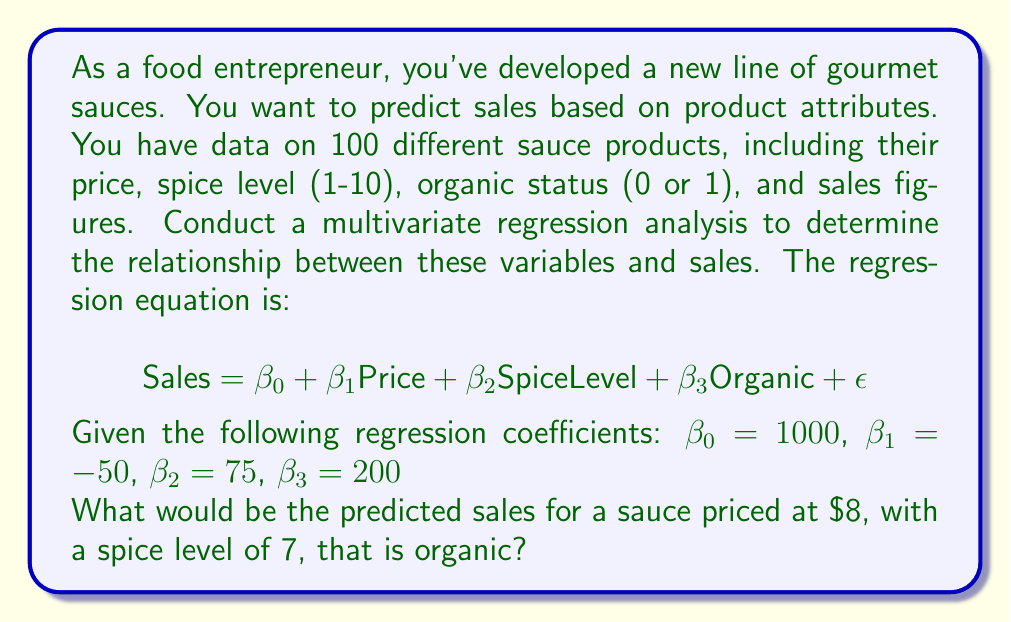Could you help me with this problem? To solve this problem, we'll follow these steps:

1. Understand the regression equation:
   $$\text{Sales} = \beta_0 + \beta_1\text{Price} + \beta_2\text{SpiceLevel} + \beta_3\text{Organic} + \epsilon$$

   Where:
   - $\beta_0$ is the y-intercept (baseline sales)
   - $\beta_1$ is the coefficient for Price
   - $\beta_2$ is the coefficient for Spice Level
   - $\beta_3$ is the coefficient for Organic status
   - $\epsilon$ is the error term (which we ignore for prediction)

2. Substitute the given coefficients:
   $$\text{Sales} = 1000 - 50\text{Price} + 75\text{SpiceLevel} + 200\text{Organic}$$

3. Input the values for our specific sauce:
   - Price = $8
   - Spice Level = 7
   - Organic = 1 (yes, it is organic)

4. Calculate the predicted sales:
   $$\begin{align*}
   \text{Sales} &= 1000 - 50(8) + 75(7) + 200(1) \\
   &= 1000 - 400 + 525 + 200
   \end{align*}$$

5. Sum up the results:
   $$\text{Sales} = 1325$$

Therefore, the predicted sales for this sauce would be 1325 units.
Answer: 1325 units 